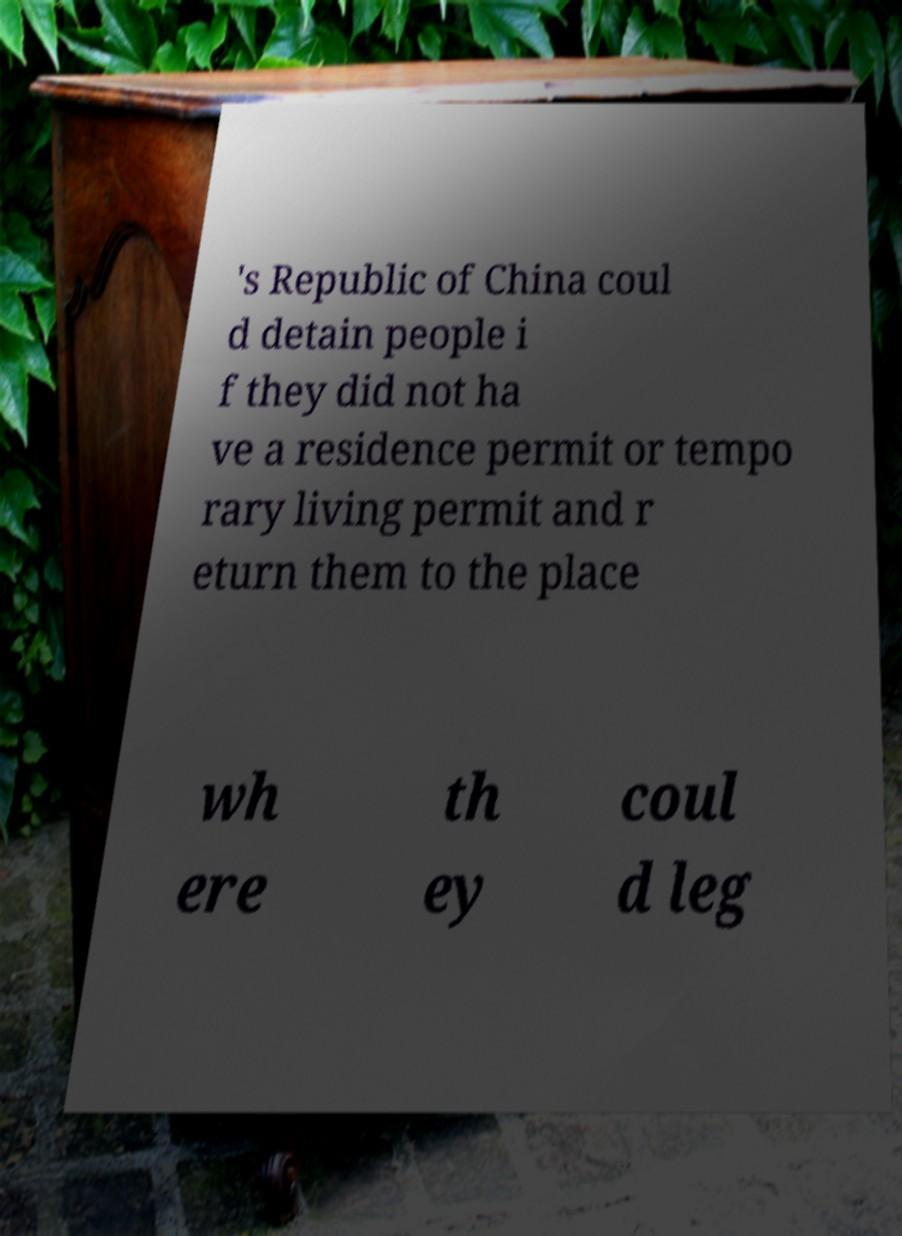Could you extract and type out the text from this image? 's Republic of China coul d detain people i f they did not ha ve a residence permit or tempo rary living permit and r eturn them to the place wh ere th ey coul d leg 